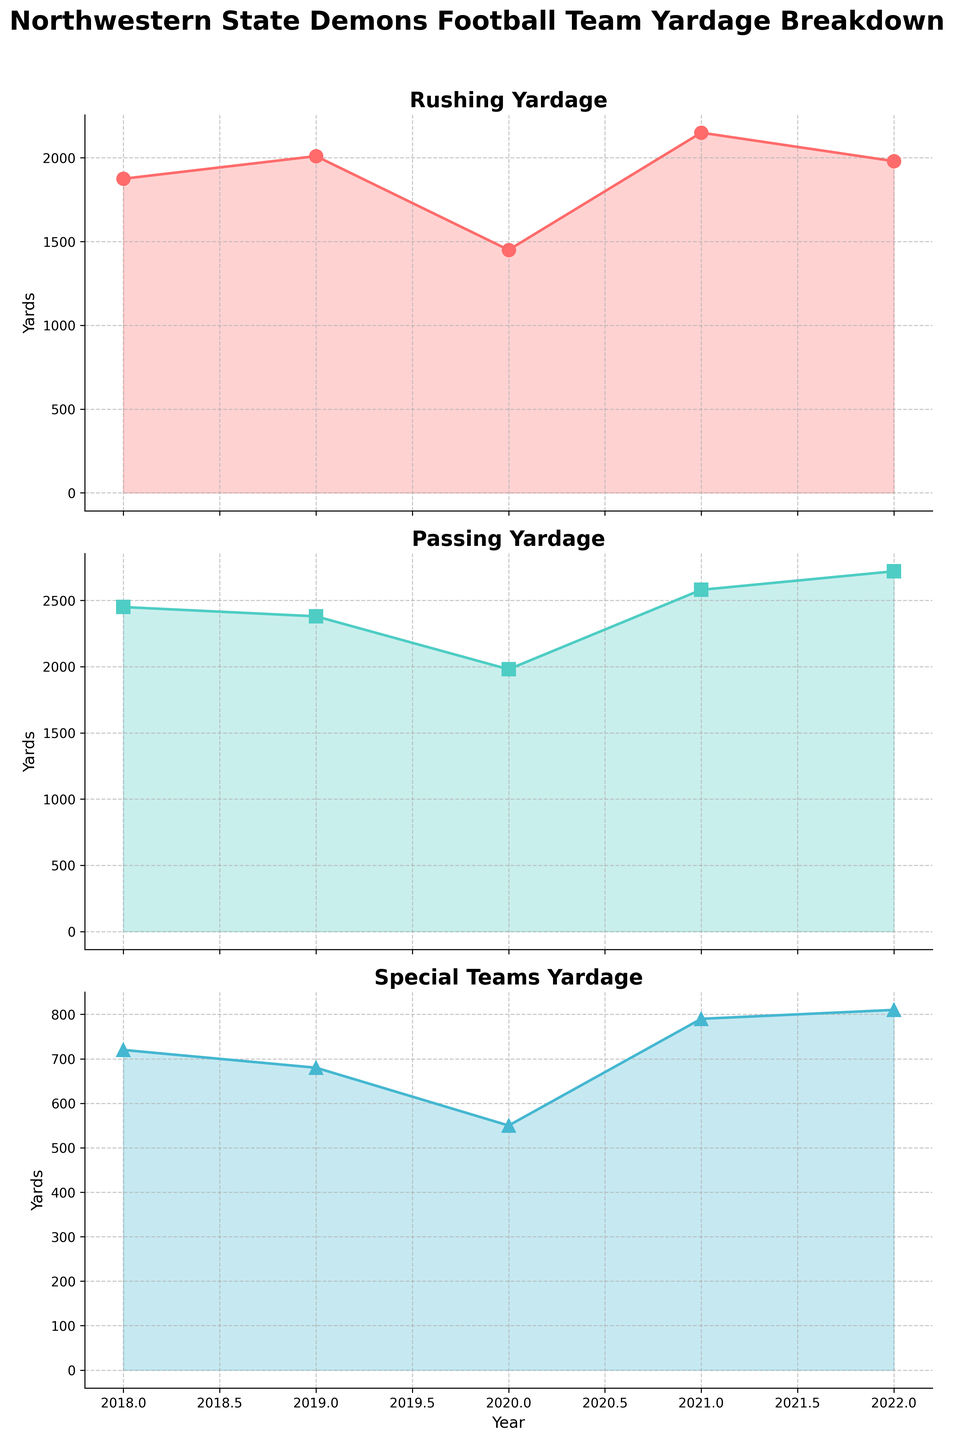What's the title of the entire figure? The title of the entire figure is located at the top of the plot. It is written in a larger and bold font for emphasis.
Answer: Northwestern State Demons Football Team Yardage Breakdown What is the rushing yardage in 2020? To find this, look at the first subplot titled "Rushing Yardage" and locate the data point for the year 2020. The value next to the data point represents the rushing yardage for that year.
Answer: 1450 How many years of data are displayed in the chart? Count the number of data points displayed along the x-axis in each subplot, as they all share the same x-axis. Each data point corresponds to a year.
Answer: 5 Which type of play has the highest yardage in 2022? Compare the values for the year 2022 in each subplot: Rushing, Passing, and Special Teams. The highest value among these is the highest yardage for that year. The "Passing Yardage" subplot shows the highest value.
Answer: Passing Which year had the lowest special teams yardage? Look at the subplot titled "Special Teams Yardage." Identify and compare the data points across different years and find the lowest value. This value corresponds to the year 2020.
Answer: 2020 What is the average passing yardage from 2018 to 2022? To calculate the average passing yardage, add the yardage values from 2018 to 2022 and divide by the number of years. The values are 2450, 2380, 1980, 2580, and 2720. The sum is (2450 + 2380 + 1980 + 2580 + 2720) = 12110. Divide by 5 to get the average.
Answer: 2422 Was there an increase or decrease in rushing yardage from 2018 to 2019? To determine this, compare the rushing yardage values for 2018 and 2019 from the "Rushing Yardage" subplot. In 2018, it’s 1875, and in 2019, it’s 2010. There’s an increase from 1875 to 2010.
Answer: Increase What was the total yardage for all types of plays in 2021? Sum the values for Rushing, Passing, and Special Teams yardage in 2021. The values are 2150 (Rushing), 2580 (Passing), and 790 (Special Teams). The total is 2150 + 2580 + 790 = 5520.
Answer: 5520 Was any type of yardage consistently increasing from 2018 to 2022? To determine consistency, observe the plots for Rushing, Passing, and Special Teams. Rushing and Special Teams exhibit fluctuation. However, Passing yardage shows an overall increasing trend.
Answer: Passing 